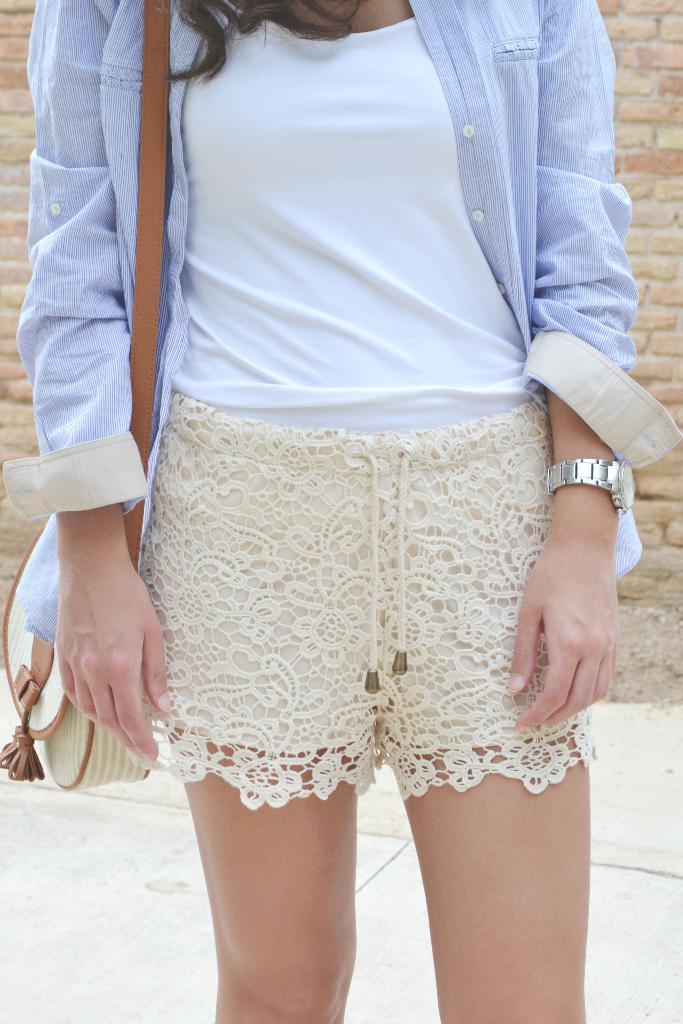In one or two sentences, can you explain what this image depicts? In the center of the image woman standing on the floor. In the background there is a wall. 